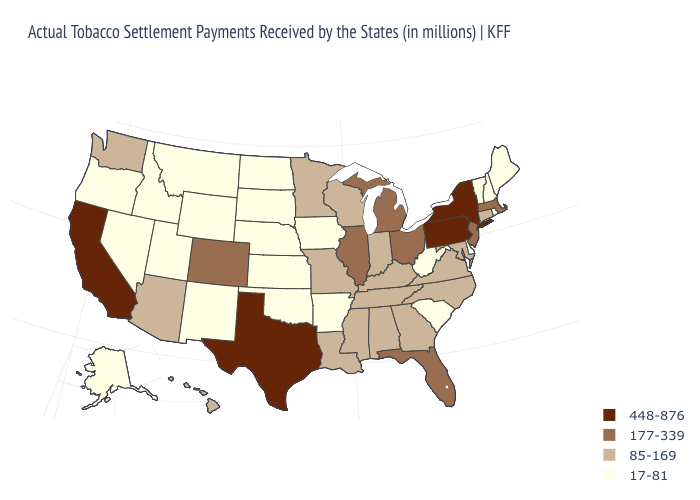Does New York have the highest value in the USA?
Answer briefly. Yes. Is the legend a continuous bar?
Give a very brief answer. No. Name the states that have a value in the range 177-339?
Short answer required. Colorado, Florida, Illinois, Massachusetts, Michigan, New Jersey, Ohio. What is the lowest value in the South?
Answer briefly. 17-81. What is the value of Tennessee?
Concise answer only. 85-169. What is the value of Michigan?
Be succinct. 177-339. Name the states that have a value in the range 177-339?
Concise answer only. Colorado, Florida, Illinois, Massachusetts, Michigan, New Jersey, Ohio. Does Missouri have the highest value in the USA?
Short answer required. No. Which states hav the highest value in the West?
Quick response, please. California. How many symbols are there in the legend?
Keep it brief. 4. Name the states that have a value in the range 448-876?
Concise answer only. California, New York, Pennsylvania, Texas. Among the states that border West Virginia , which have the highest value?
Give a very brief answer. Pennsylvania. What is the value of Oregon?
Concise answer only. 17-81. Among the states that border Oklahoma , does Arkansas have the highest value?
Keep it brief. No. 